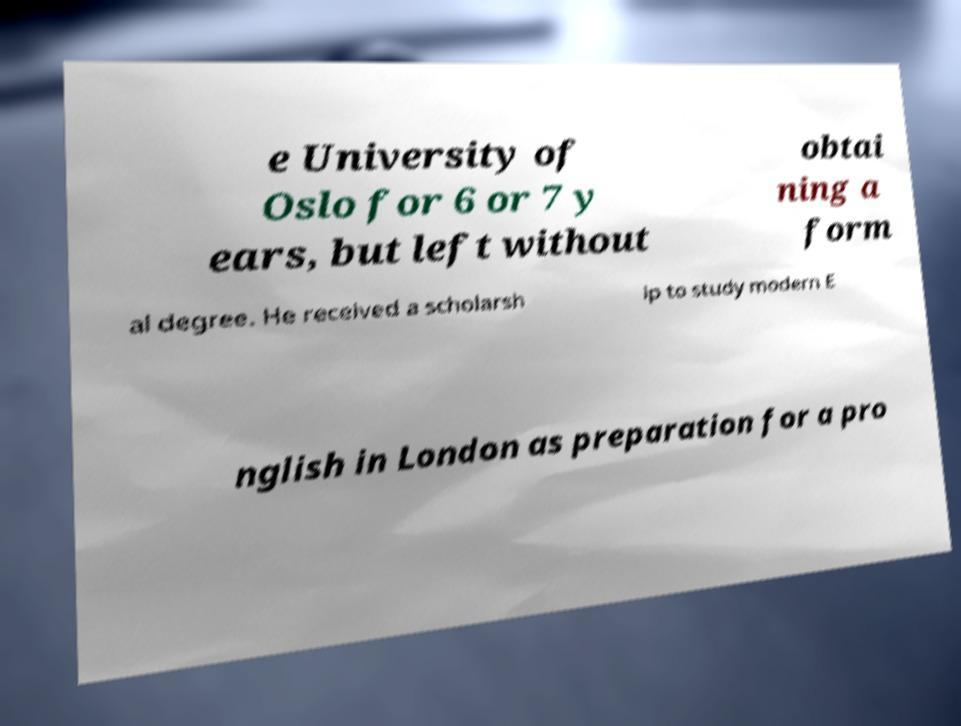For documentation purposes, I need the text within this image transcribed. Could you provide that? e University of Oslo for 6 or 7 y ears, but left without obtai ning a form al degree. He received a scholarsh ip to study modern E nglish in London as preparation for a pro 